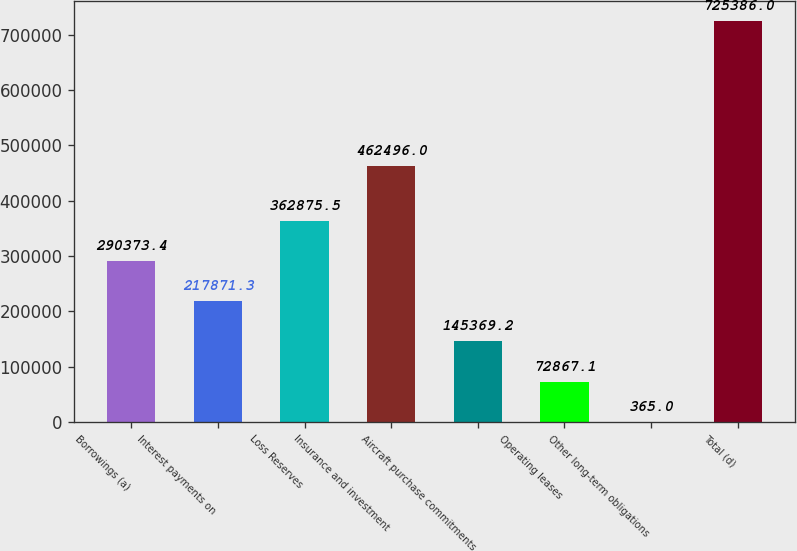<chart> <loc_0><loc_0><loc_500><loc_500><bar_chart><fcel>Borrowings (a)<fcel>Interest payments on<fcel>Loss Reserves<fcel>Insurance and investment<fcel>Aircraft purchase commitments<fcel>Operating leases<fcel>Other long-term obligations<fcel>Total (d)<nl><fcel>290373<fcel>217871<fcel>362876<fcel>462496<fcel>145369<fcel>72867.1<fcel>365<fcel>725386<nl></chart> 